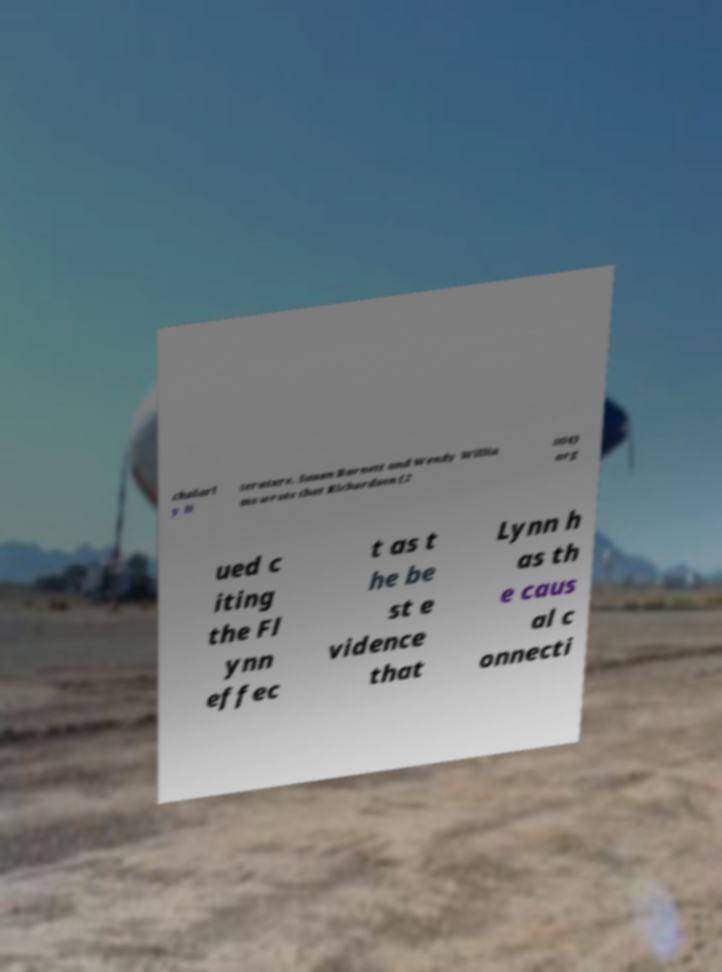Could you assist in decoding the text presented in this image and type it out clearly? cholarl y li terature. Susan Barnett and Wendy Willia ms wrote that Richardson (2 004) arg ued c iting the Fl ynn effec t as t he be st e vidence that Lynn h as th e caus al c onnecti 